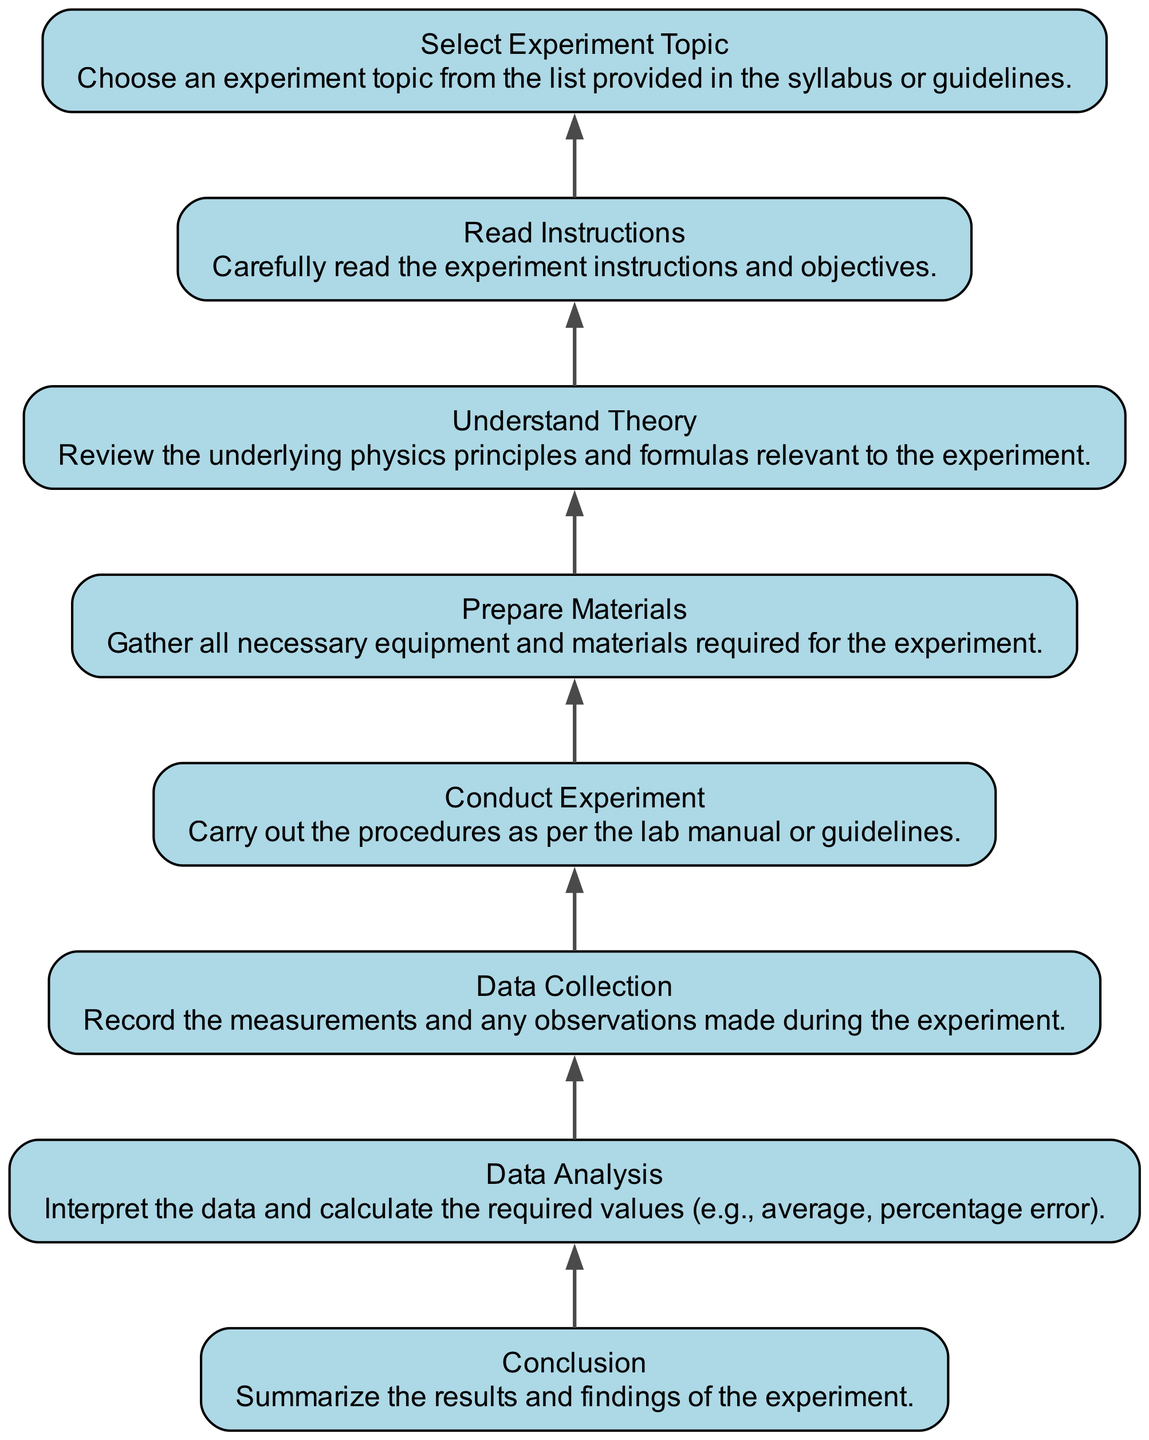What is the final step in the workflow? The diagram flows from bottom to up, and the topmost node is labeled "Conclusion," indicating it is the final step in the workflow process.
Answer: Conclusion How many nodes are present in the diagram? By counting the elements listed, there are eight distinct steps or nodes in the workflow diagram.
Answer: Eight Which step comes before "Data Analysis"? In the flow chart, "Data Analysis" is directly preceded by "Data Collection," making it the step that comes before it.
Answer: Data Collection What is the first step in the workflow? The bottom node labeled "Select Experiment Topic" is the first step in the workflow, indicating the starting point of the process.
Answer: Select Experiment Topic What step follows "Conduct Experiment"? The diagram shows that "Conduct Experiment" is directly followed by "Data Collection," indicating the sequence of steps.
Answer: Data Collection How does "Understand Theory" relate to "Prepare Materials"? In the diagram, "Understand Theory" precedes "Prepare Materials," indicating that reviewing the underlying principles is required before gathering materials.
Answer: Understand Theory How many steps are between "Read Instructions" and "Conclusion"? Counting the steps in the diagram from "Read Instructions" to "Conclusion," there are five steps in between these two nodes.
Answer: Five Which step requires a review of physics principles? The node labeled "Understand Theory" explicitly mentions reviewing underlying physics principles, making it the step that addresses this requirement.
Answer: Understand Theory Which two steps are directly connected to "Data Analysis"? "Data Collection" is directly connected before "Data Analysis," and "Conclusion" is directly connected after it, forming a link with these two nodes.
Answer: Data Collection and Conclusion 